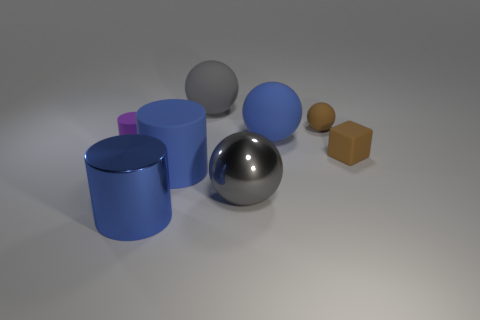Subtract all large blue cylinders. How many cylinders are left? 1 Add 1 purple cylinders. How many objects exist? 9 Subtract all purple cylinders. How many cylinders are left? 2 Subtract all cylinders. How many objects are left? 5 Subtract 1 blocks. How many blocks are left? 0 Add 2 blue balls. How many blue balls exist? 3 Subtract 0 yellow cylinders. How many objects are left? 8 Subtract all yellow cylinders. Subtract all gray blocks. How many cylinders are left? 3 Subtract all gray cylinders. How many brown spheres are left? 1 Subtract all big red cylinders. Subtract all metallic balls. How many objects are left? 7 